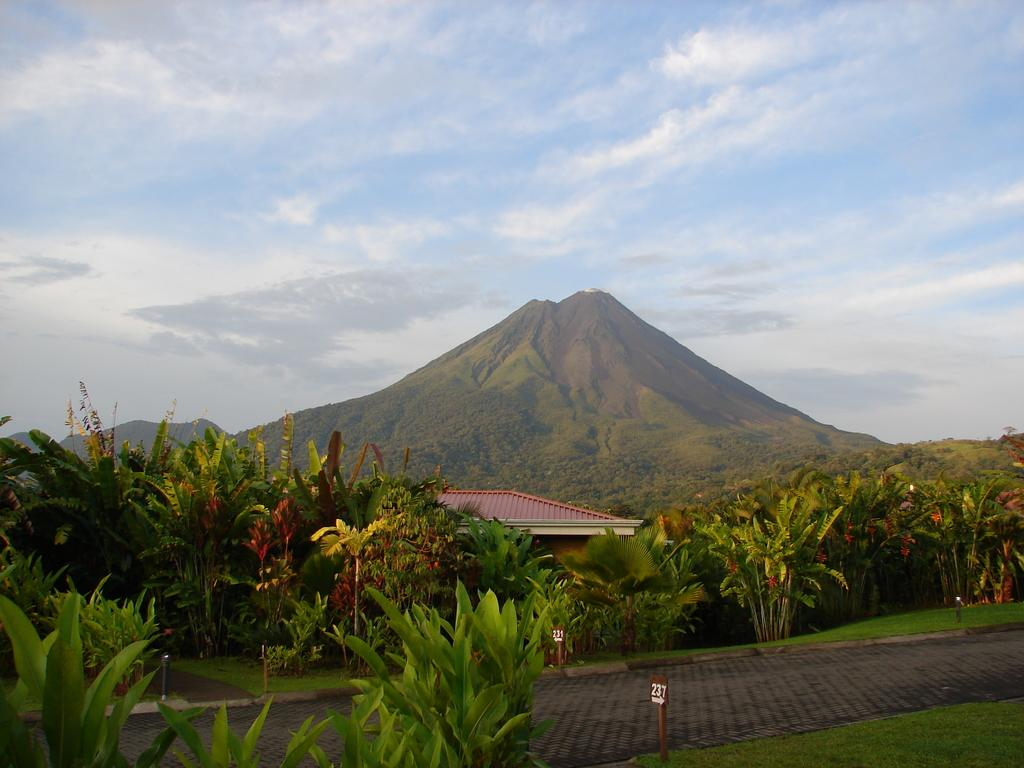What type of natural elements can be seen in the image? There are plants, trees, and mountains visible in the image. What man-made structures are present in the image? There are poles, boards, and a house in the image. What is visible in the background of the image? The sky with clouds is visible in the background of the image. How many boys are playing with the worm on the nail in the image? There are no boys, worms, or nails present in the image. 